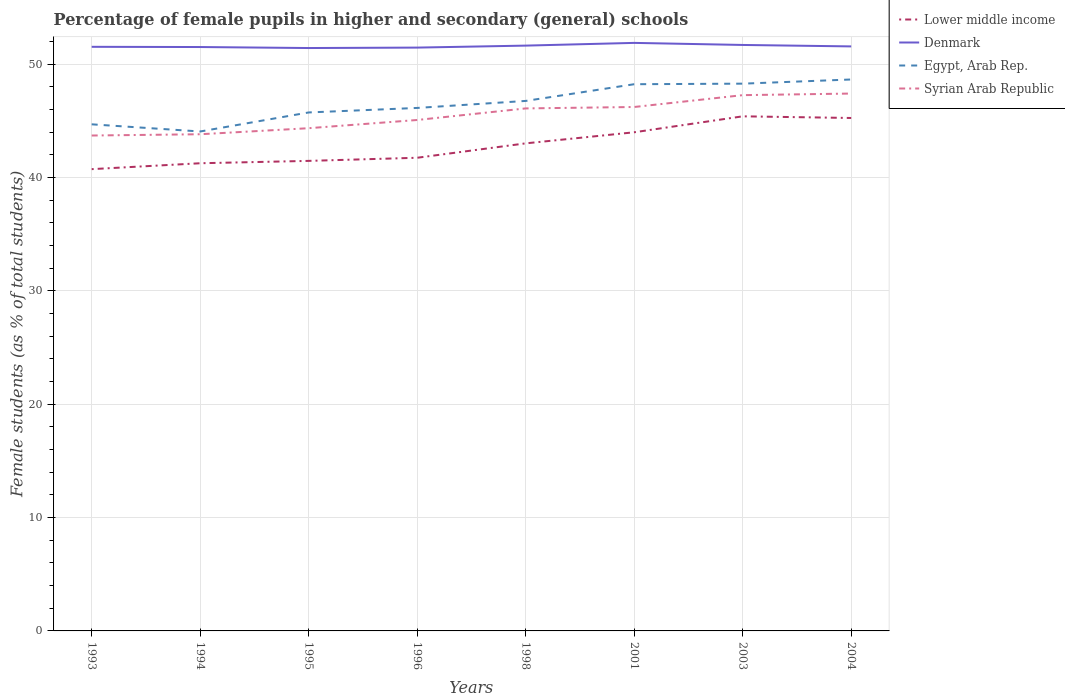Across all years, what is the maximum percentage of female pupils in higher and secondary schools in Lower middle income?
Make the answer very short. 40.74. In which year was the percentage of female pupils in higher and secondary schools in Denmark maximum?
Provide a succinct answer. 1995. What is the total percentage of female pupils in higher and secondary schools in Egypt, Arab Rep. in the graph?
Your response must be concise. -2.06. What is the difference between the highest and the second highest percentage of female pupils in higher and secondary schools in Egypt, Arab Rep.?
Your answer should be very brief. 4.59. Is the percentage of female pupils in higher and secondary schools in Lower middle income strictly greater than the percentage of female pupils in higher and secondary schools in Denmark over the years?
Offer a terse response. Yes. What is the difference between two consecutive major ticks on the Y-axis?
Your response must be concise. 10. Are the values on the major ticks of Y-axis written in scientific E-notation?
Provide a succinct answer. No. Does the graph contain grids?
Your answer should be compact. Yes. How many legend labels are there?
Keep it short and to the point. 4. What is the title of the graph?
Give a very brief answer. Percentage of female pupils in higher and secondary (general) schools. What is the label or title of the X-axis?
Provide a short and direct response. Years. What is the label or title of the Y-axis?
Your answer should be very brief. Female students (as % of total students). What is the Female students (as % of total students) in Lower middle income in 1993?
Keep it short and to the point. 40.74. What is the Female students (as % of total students) of Denmark in 1993?
Make the answer very short. 51.54. What is the Female students (as % of total students) of Egypt, Arab Rep. in 1993?
Make the answer very short. 44.7. What is the Female students (as % of total students) in Syrian Arab Republic in 1993?
Provide a short and direct response. 43.71. What is the Female students (as % of total students) of Lower middle income in 1994?
Make the answer very short. 41.27. What is the Female students (as % of total students) in Denmark in 1994?
Provide a short and direct response. 51.52. What is the Female students (as % of total students) of Egypt, Arab Rep. in 1994?
Keep it short and to the point. 44.07. What is the Female students (as % of total students) in Syrian Arab Republic in 1994?
Offer a terse response. 43.82. What is the Female students (as % of total students) of Lower middle income in 1995?
Keep it short and to the point. 41.47. What is the Female students (as % of total students) of Denmark in 1995?
Make the answer very short. 51.43. What is the Female students (as % of total students) of Egypt, Arab Rep. in 1995?
Keep it short and to the point. 45.75. What is the Female students (as % of total students) of Syrian Arab Republic in 1995?
Offer a terse response. 44.36. What is the Female students (as % of total students) of Lower middle income in 1996?
Provide a short and direct response. 41.75. What is the Female students (as % of total students) of Denmark in 1996?
Keep it short and to the point. 51.47. What is the Female students (as % of total students) in Egypt, Arab Rep. in 1996?
Give a very brief answer. 46.15. What is the Female students (as % of total students) in Syrian Arab Republic in 1996?
Your answer should be very brief. 45.08. What is the Female students (as % of total students) of Lower middle income in 1998?
Ensure brevity in your answer.  43.02. What is the Female students (as % of total students) in Denmark in 1998?
Provide a short and direct response. 51.65. What is the Female students (as % of total students) of Egypt, Arab Rep. in 1998?
Make the answer very short. 46.76. What is the Female students (as % of total students) in Syrian Arab Republic in 1998?
Your response must be concise. 46.1. What is the Female students (as % of total students) in Lower middle income in 2001?
Offer a very short reply. 44. What is the Female students (as % of total students) in Denmark in 2001?
Provide a short and direct response. 51.89. What is the Female students (as % of total students) of Egypt, Arab Rep. in 2001?
Give a very brief answer. 48.24. What is the Female students (as % of total students) of Syrian Arab Republic in 2001?
Your response must be concise. 46.23. What is the Female students (as % of total students) in Lower middle income in 2003?
Your answer should be compact. 45.41. What is the Female students (as % of total students) of Denmark in 2003?
Your answer should be compact. 51.7. What is the Female students (as % of total students) in Egypt, Arab Rep. in 2003?
Provide a succinct answer. 48.29. What is the Female students (as % of total students) in Syrian Arab Republic in 2003?
Keep it short and to the point. 47.27. What is the Female students (as % of total students) of Lower middle income in 2004?
Give a very brief answer. 45.26. What is the Female students (as % of total students) of Denmark in 2004?
Make the answer very short. 51.57. What is the Female students (as % of total students) of Egypt, Arab Rep. in 2004?
Give a very brief answer. 48.66. What is the Female students (as % of total students) in Syrian Arab Republic in 2004?
Your response must be concise. 47.42. Across all years, what is the maximum Female students (as % of total students) of Lower middle income?
Give a very brief answer. 45.41. Across all years, what is the maximum Female students (as % of total students) of Denmark?
Offer a very short reply. 51.89. Across all years, what is the maximum Female students (as % of total students) in Egypt, Arab Rep.?
Give a very brief answer. 48.66. Across all years, what is the maximum Female students (as % of total students) of Syrian Arab Republic?
Give a very brief answer. 47.42. Across all years, what is the minimum Female students (as % of total students) in Lower middle income?
Offer a terse response. 40.74. Across all years, what is the minimum Female students (as % of total students) of Denmark?
Offer a very short reply. 51.43. Across all years, what is the minimum Female students (as % of total students) in Egypt, Arab Rep.?
Provide a short and direct response. 44.07. Across all years, what is the minimum Female students (as % of total students) of Syrian Arab Republic?
Provide a succinct answer. 43.71. What is the total Female students (as % of total students) in Lower middle income in the graph?
Your answer should be compact. 342.92. What is the total Female students (as % of total students) of Denmark in the graph?
Keep it short and to the point. 412.77. What is the total Female students (as % of total students) of Egypt, Arab Rep. in the graph?
Provide a short and direct response. 372.61. What is the total Female students (as % of total students) in Syrian Arab Republic in the graph?
Make the answer very short. 364. What is the difference between the Female students (as % of total students) in Lower middle income in 1993 and that in 1994?
Provide a succinct answer. -0.52. What is the difference between the Female students (as % of total students) of Denmark in 1993 and that in 1994?
Offer a terse response. 0.02. What is the difference between the Female students (as % of total students) in Egypt, Arab Rep. in 1993 and that in 1994?
Your answer should be compact. 0.63. What is the difference between the Female students (as % of total students) in Syrian Arab Republic in 1993 and that in 1994?
Make the answer very short. -0.11. What is the difference between the Female students (as % of total students) in Lower middle income in 1993 and that in 1995?
Offer a terse response. -0.73. What is the difference between the Female students (as % of total students) of Denmark in 1993 and that in 1995?
Your answer should be compact. 0.11. What is the difference between the Female students (as % of total students) of Egypt, Arab Rep. in 1993 and that in 1995?
Provide a succinct answer. -1.05. What is the difference between the Female students (as % of total students) of Syrian Arab Republic in 1993 and that in 1995?
Your answer should be compact. -0.65. What is the difference between the Female students (as % of total students) in Lower middle income in 1993 and that in 1996?
Your answer should be very brief. -1.01. What is the difference between the Female students (as % of total students) of Denmark in 1993 and that in 1996?
Your answer should be compact. 0.07. What is the difference between the Female students (as % of total students) in Egypt, Arab Rep. in 1993 and that in 1996?
Ensure brevity in your answer.  -1.45. What is the difference between the Female students (as % of total students) in Syrian Arab Republic in 1993 and that in 1996?
Your response must be concise. -1.37. What is the difference between the Female students (as % of total students) of Lower middle income in 1993 and that in 1998?
Offer a terse response. -2.28. What is the difference between the Female students (as % of total students) in Denmark in 1993 and that in 1998?
Your answer should be compact. -0.11. What is the difference between the Female students (as % of total students) of Egypt, Arab Rep. in 1993 and that in 1998?
Ensure brevity in your answer.  -2.06. What is the difference between the Female students (as % of total students) in Syrian Arab Republic in 1993 and that in 1998?
Your answer should be very brief. -2.39. What is the difference between the Female students (as % of total students) of Lower middle income in 1993 and that in 2001?
Offer a terse response. -3.25. What is the difference between the Female students (as % of total students) in Denmark in 1993 and that in 2001?
Provide a short and direct response. -0.35. What is the difference between the Female students (as % of total students) of Egypt, Arab Rep. in 1993 and that in 2001?
Make the answer very short. -3.54. What is the difference between the Female students (as % of total students) in Syrian Arab Republic in 1993 and that in 2001?
Make the answer very short. -2.52. What is the difference between the Female students (as % of total students) in Lower middle income in 1993 and that in 2003?
Make the answer very short. -4.66. What is the difference between the Female students (as % of total students) in Denmark in 1993 and that in 2003?
Offer a very short reply. -0.17. What is the difference between the Female students (as % of total students) in Egypt, Arab Rep. in 1993 and that in 2003?
Your answer should be very brief. -3.59. What is the difference between the Female students (as % of total students) in Syrian Arab Republic in 1993 and that in 2003?
Offer a very short reply. -3.56. What is the difference between the Female students (as % of total students) in Lower middle income in 1993 and that in 2004?
Your answer should be very brief. -4.51. What is the difference between the Female students (as % of total students) in Denmark in 1993 and that in 2004?
Ensure brevity in your answer.  -0.04. What is the difference between the Female students (as % of total students) in Egypt, Arab Rep. in 1993 and that in 2004?
Keep it short and to the point. -3.96. What is the difference between the Female students (as % of total students) of Syrian Arab Republic in 1993 and that in 2004?
Make the answer very short. -3.7. What is the difference between the Female students (as % of total students) in Lower middle income in 1994 and that in 1995?
Offer a terse response. -0.21. What is the difference between the Female students (as % of total students) in Denmark in 1994 and that in 1995?
Provide a succinct answer. 0.09. What is the difference between the Female students (as % of total students) of Egypt, Arab Rep. in 1994 and that in 1995?
Give a very brief answer. -1.68. What is the difference between the Female students (as % of total students) in Syrian Arab Republic in 1994 and that in 1995?
Give a very brief answer. -0.53. What is the difference between the Female students (as % of total students) in Lower middle income in 1994 and that in 1996?
Provide a short and direct response. -0.48. What is the difference between the Female students (as % of total students) of Denmark in 1994 and that in 1996?
Offer a very short reply. 0.05. What is the difference between the Female students (as % of total students) in Egypt, Arab Rep. in 1994 and that in 1996?
Provide a short and direct response. -2.08. What is the difference between the Female students (as % of total students) of Syrian Arab Republic in 1994 and that in 1996?
Make the answer very short. -1.26. What is the difference between the Female students (as % of total students) of Lower middle income in 1994 and that in 1998?
Offer a terse response. -1.75. What is the difference between the Female students (as % of total students) in Denmark in 1994 and that in 1998?
Offer a very short reply. -0.13. What is the difference between the Female students (as % of total students) of Egypt, Arab Rep. in 1994 and that in 1998?
Give a very brief answer. -2.7. What is the difference between the Female students (as % of total students) of Syrian Arab Republic in 1994 and that in 1998?
Ensure brevity in your answer.  -2.28. What is the difference between the Female students (as % of total students) of Lower middle income in 1994 and that in 2001?
Your answer should be very brief. -2.73. What is the difference between the Female students (as % of total students) of Denmark in 1994 and that in 2001?
Your response must be concise. -0.37. What is the difference between the Female students (as % of total students) in Egypt, Arab Rep. in 1994 and that in 2001?
Your answer should be very brief. -4.17. What is the difference between the Female students (as % of total students) in Syrian Arab Republic in 1994 and that in 2001?
Your response must be concise. -2.4. What is the difference between the Female students (as % of total students) of Lower middle income in 1994 and that in 2003?
Your answer should be very brief. -4.14. What is the difference between the Female students (as % of total students) in Denmark in 1994 and that in 2003?
Your answer should be compact. -0.18. What is the difference between the Female students (as % of total students) of Egypt, Arab Rep. in 1994 and that in 2003?
Keep it short and to the point. -4.22. What is the difference between the Female students (as % of total students) of Syrian Arab Republic in 1994 and that in 2003?
Ensure brevity in your answer.  -3.45. What is the difference between the Female students (as % of total students) in Lower middle income in 1994 and that in 2004?
Make the answer very short. -3.99. What is the difference between the Female students (as % of total students) of Denmark in 1994 and that in 2004?
Offer a terse response. -0.06. What is the difference between the Female students (as % of total students) in Egypt, Arab Rep. in 1994 and that in 2004?
Your response must be concise. -4.59. What is the difference between the Female students (as % of total students) of Syrian Arab Republic in 1994 and that in 2004?
Provide a succinct answer. -3.59. What is the difference between the Female students (as % of total students) in Lower middle income in 1995 and that in 1996?
Provide a short and direct response. -0.28. What is the difference between the Female students (as % of total students) in Denmark in 1995 and that in 1996?
Your answer should be compact. -0.04. What is the difference between the Female students (as % of total students) in Egypt, Arab Rep. in 1995 and that in 1996?
Keep it short and to the point. -0.4. What is the difference between the Female students (as % of total students) of Syrian Arab Republic in 1995 and that in 1996?
Offer a very short reply. -0.72. What is the difference between the Female students (as % of total students) of Lower middle income in 1995 and that in 1998?
Offer a very short reply. -1.55. What is the difference between the Female students (as % of total students) in Denmark in 1995 and that in 1998?
Provide a succinct answer. -0.21. What is the difference between the Female students (as % of total students) in Egypt, Arab Rep. in 1995 and that in 1998?
Keep it short and to the point. -1.02. What is the difference between the Female students (as % of total students) of Syrian Arab Republic in 1995 and that in 1998?
Offer a terse response. -1.75. What is the difference between the Female students (as % of total students) in Lower middle income in 1995 and that in 2001?
Keep it short and to the point. -2.52. What is the difference between the Female students (as % of total students) of Denmark in 1995 and that in 2001?
Keep it short and to the point. -0.45. What is the difference between the Female students (as % of total students) in Egypt, Arab Rep. in 1995 and that in 2001?
Your answer should be very brief. -2.49. What is the difference between the Female students (as % of total students) of Syrian Arab Republic in 1995 and that in 2001?
Keep it short and to the point. -1.87. What is the difference between the Female students (as % of total students) of Lower middle income in 1995 and that in 2003?
Your answer should be compact. -3.93. What is the difference between the Female students (as % of total students) in Denmark in 1995 and that in 2003?
Offer a terse response. -0.27. What is the difference between the Female students (as % of total students) of Egypt, Arab Rep. in 1995 and that in 2003?
Your answer should be very brief. -2.54. What is the difference between the Female students (as % of total students) in Syrian Arab Republic in 1995 and that in 2003?
Offer a terse response. -2.92. What is the difference between the Female students (as % of total students) in Lower middle income in 1995 and that in 2004?
Ensure brevity in your answer.  -3.78. What is the difference between the Female students (as % of total students) in Denmark in 1995 and that in 2004?
Offer a very short reply. -0.14. What is the difference between the Female students (as % of total students) in Egypt, Arab Rep. in 1995 and that in 2004?
Your response must be concise. -2.91. What is the difference between the Female students (as % of total students) of Syrian Arab Republic in 1995 and that in 2004?
Ensure brevity in your answer.  -3.06. What is the difference between the Female students (as % of total students) of Lower middle income in 1996 and that in 1998?
Offer a very short reply. -1.27. What is the difference between the Female students (as % of total students) of Denmark in 1996 and that in 1998?
Offer a terse response. -0.18. What is the difference between the Female students (as % of total students) of Egypt, Arab Rep. in 1996 and that in 1998?
Provide a succinct answer. -0.62. What is the difference between the Female students (as % of total students) of Syrian Arab Republic in 1996 and that in 1998?
Your answer should be compact. -1.02. What is the difference between the Female students (as % of total students) of Lower middle income in 1996 and that in 2001?
Your answer should be compact. -2.25. What is the difference between the Female students (as % of total students) of Denmark in 1996 and that in 2001?
Your response must be concise. -0.41. What is the difference between the Female students (as % of total students) of Egypt, Arab Rep. in 1996 and that in 2001?
Your answer should be compact. -2.09. What is the difference between the Female students (as % of total students) in Syrian Arab Republic in 1996 and that in 2001?
Ensure brevity in your answer.  -1.15. What is the difference between the Female students (as % of total students) of Lower middle income in 1996 and that in 2003?
Provide a succinct answer. -3.66. What is the difference between the Female students (as % of total students) of Denmark in 1996 and that in 2003?
Give a very brief answer. -0.23. What is the difference between the Female students (as % of total students) of Egypt, Arab Rep. in 1996 and that in 2003?
Your answer should be very brief. -2.14. What is the difference between the Female students (as % of total students) of Syrian Arab Republic in 1996 and that in 2003?
Offer a very short reply. -2.19. What is the difference between the Female students (as % of total students) of Lower middle income in 1996 and that in 2004?
Offer a very short reply. -3.51. What is the difference between the Female students (as % of total students) of Denmark in 1996 and that in 2004?
Provide a short and direct response. -0.1. What is the difference between the Female students (as % of total students) of Egypt, Arab Rep. in 1996 and that in 2004?
Provide a succinct answer. -2.51. What is the difference between the Female students (as % of total students) of Syrian Arab Republic in 1996 and that in 2004?
Your response must be concise. -2.33. What is the difference between the Female students (as % of total students) in Lower middle income in 1998 and that in 2001?
Ensure brevity in your answer.  -0.98. What is the difference between the Female students (as % of total students) of Denmark in 1998 and that in 2001?
Keep it short and to the point. -0.24. What is the difference between the Female students (as % of total students) in Egypt, Arab Rep. in 1998 and that in 2001?
Give a very brief answer. -1.47. What is the difference between the Female students (as % of total students) of Syrian Arab Republic in 1998 and that in 2001?
Offer a terse response. -0.13. What is the difference between the Female students (as % of total students) in Lower middle income in 1998 and that in 2003?
Offer a terse response. -2.39. What is the difference between the Female students (as % of total students) in Denmark in 1998 and that in 2003?
Make the answer very short. -0.06. What is the difference between the Female students (as % of total students) of Egypt, Arab Rep. in 1998 and that in 2003?
Offer a very short reply. -1.52. What is the difference between the Female students (as % of total students) in Syrian Arab Republic in 1998 and that in 2003?
Give a very brief answer. -1.17. What is the difference between the Female students (as % of total students) of Lower middle income in 1998 and that in 2004?
Keep it short and to the point. -2.24. What is the difference between the Female students (as % of total students) of Denmark in 1998 and that in 2004?
Your response must be concise. 0.07. What is the difference between the Female students (as % of total students) in Egypt, Arab Rep. in 1998 and that in 2004?
Give a very brief answer. -1.89. What is the difference between the Female students (as % of total students) of Syrian Arab Republic in 1998 and that in 2004?
Your answer should be compact. -1.31. What is the difference between the Female students (as % of total students) of Lower middle income in 2001 and that in 2003?
Ensure brevity in your answer.  -1.41. What is the difference between the Female students (as % of total students) of Denmark in 2001 and that in 2003?
Your response must be concise. 0.18. What is the difference between the Female students (as % of total students) in Egypt, Arab Rep. in 2001 and that in 2003?
Give a very brief answer. -0.05. What is the difference between the Female students (as % of total students) of Syrian Arab Republic in 2001 and that in 2003?
Provide a short and direct response. -1.05. What is the difference between the Female students (as % of total students) in Lower middle income in 2001 and that in 2004?
Keep it short and to the point. -1.26. What is the difference between the Female students (as % of total students) of Denmark in 2001 and that in 2004?
Offer a very short reply. 0.31. What is the difference between the Female students (as % of total students) of Egypt, Arab Rep. in 2001 and that in 2004?
Give a very brief answer. -0.42. What is the difference between the Female students (as % of total students) in Syrian Arab Republic in 2001 and that in 2004?
Your response must be concise. -1.19. What is the difference between the Female students (as % of total students) of Lower middle income in 2003 and that in 2004?
Your answer should be very brief. 0.15. What is the difference between the Female students (as % of total students) of Denmark in 2003 and that in 2004?
Offer a very short reply. 0.13. What is the difference between the Female students (as % of total students) in Egypt, Arab Rep. in 2003 and that in 2004?
Your answer should be very brief. -0.37. What is the difference between the Female students (as % of total students) of Syrian Arab Republic in 2003 and that in 2004?
Offer a terse response. -0.14. What is the difference between the Female students (as % of total students) in Lower middle income in 1993 and the Female students (as % of total students) in Denmark in 1994?
Offer a very short reply. -10.78. What is the difference between the Female students (as % of total students) in Lower middle income in 1993 and the Female students (as % of total students) in Egypt, Arab Rep. in 1994?
Make the answer very short. -3.32. What is the difference between the Female students (as % of total students) of Lower middle income in 1993 and the Female students (as % of total students) of Syrian Arab Republic in 1994?
Your response must be concise. -3.08. What is the difference between the Female students (as % of total students) in Denmark in 1993 and the Female students (as % of total students) in Egypt, Arab Rep. in 1994?
Your response must be concise. 7.47. What is the difference between the Female students (as % of total students) of Denmark in 1993 and the Female students (as % of total students) of Syrian Arab Republic in 1994?
Keep it short and to the point. 7.71. What is the difference between the Female students (as % of total students) of Egypt, Arab Rep. in 1993 and the Female students (as % of total students) of Syrian Arab Republic in 1994?
Give a very brief answer. 0.88. What is the difference between the Female students (as % of total students) of Lower middle income in 1993 and the Female students (as % of total students) of Denmark in 1995?
Provide a short and direct response. -10.69. What is the difference between the Female students (as % of total students) of Lower middle income in 1993 and the Female students (as % of total students) of Egypt, Arab Rep. in 1995?
Keep it short and to the point. -5. What is the difference between the Female students (as % of total students) of Lower middle income in 1993 and the Female students (as % of total students) of Syrian Arab Republic in 1995?
Your response must be concise. -3.61. What is the difference between the Female students (as % of total students) in Denmark in 1993 and the Female students (as % of total students) in Egypt, Arab Rep. in 1995?
Your answer should be compact. 5.79. What is the difference between the Female students (as % of total students) in Denmark in 1993 and the Female students (as % of total students) in Syrian Arab Republic in 1995?
Your answer should be compact. 7.18. What is the difference between the Female students (as % of total students) of Egypt, Arab Rep. in 1993 and the Female students (as % of total students) of Syrian Arab Republic in 1995?
Your response must be concise. 0.34. What is the difference between the Female students (as % of total students) of Lower middle income in 1993 and the Female students (as % of total students) of Denmark in 1996?
Offer a very short reply. -10.73. What is the difference between the Female students (as % of total students) in Lower middle income in 1993 and the Female students (as % of total students) in Egypt, Arab Rep. in 1996?
Make the answer very short. -5.4. What is the difference between the Female students (as % of total students) of Lower middle income in 1993 and the Female students (as % of total students) of Syrian Arab Republic in 1996?
Your response must be concise. -4.34. What is the difference between the Female students (as % of total students) in Denmark in 1993 and the Female students (as % of total students) in Egypt, Arab Rep. in 1996?
Give a very brief answer. 5.39. What is the difference between the Female students (as % of total students) of Denmark in 1993 and the Female students (as % of total students) of Syrian Arab Republic in 1996?
Your answer should be very brief. 6.46. What is the difference between the Female students (as % of total students) of Egypt, Arab Rep. in 1993 and the Female students (as % of total students) of Syrian Arab Republic in 1996?
Provide a short and direct response. -0.38. What is the difference between the Female students (as % of total students) in Lower middle income in 1993 and the Female students (as % of total students) in Denmark in 1998?
Provide a succinct answer. -10.9. What is the difference between the Female students (as % of total students) of Lower middle income in 1993 and the Female students (as % of total students) of Egypt, Arab Rep. in 1998?
Offer a terse response. -6.02. What is the difference between the Female students (as % of total students) of Lower middle income in 1993 and the Female students (as % of total students) of Syrian Arab Republic in 1998?
Ensure brevity in your answer.  -5.36. What is the difference between the Female students (as % of total students) in Denmark in 1993 and the Female students (as % of total students) in Egypt, Arab Rep. in 1998?
Give a very brief answer. 4.77. What is the difference between the Female students (as % of total students) of Denmark in 1993 and the Female students (as % of total students) of Syrian Arab Republic in 1998?
Offer a very short reply. 5.44. What is the difference between the Female students (as % of total students) in Egypt, Arab Rep. in 1993 and the Female students (as % of total students) in Syrian Arab Republic in 1998?
Your answer should be compact. -1.4. What is the difference between the Female students (as % of total students) of Lower middle income in 1993 and the Female students (as % of total students) of Denmark in 2001?
Make the answer very short. -11.14. What is the difference between the Female students (as % of total students) in Lower middle income in 1993 and the Female students (as % of total students) in Egypt, Arab Rep. in 2001?
Make the answer very short. -7.49. What is the difference between the Female students (as % of total students) of Lower middle income in 1993 and the Female students (as % of total students) of Syrian Arab Republic in 2001?
Give a very brief answer. -5.48. What is the difference between the Female students (as % of total students) in Denmark in 1993 and the Female students (as % of total students) in Egypt, Arab Rep. in 2001?
Your answer should be compact. 3.3. What is the difference between the Female students (as % of total students) in Denmark in 1993 and the Female students (as % of total students) in Syrian Arab Republic in 2001?
Keep it short and to the point. 5.31. What is the difference between the Female students (as % of total students) in Egypt, Arab Rep. in 1993 and the Female students (as % of total students) in Syrian Arab Republic in 2001?
Ensure brevity in your answer.  -1.53. What is the difference between the Female students (as % of total students) of Lower middle income in 1993 and the Female students (as % of total students) of Denmark in 2003?
Keep it short and to the point. -10.96. What is the difference between the Female students (as % of total students) in Lower middle income in 1993 and the Female students (as % of total students) in Egypt, Arab Rep. in 2003?
Offer a terse response. -7.54. What is the difference between the Female students (as % of total students) of Lower middle income in 1993 and the Female students (as % of total students) of Syrian Arab Republic in 2003?
Your answer should be very brief. -6.53. What is the difference between the Female students (as % of total students) of Denmark in 1993 and the Female students (as % of total students) of Egypt, Arab Rep. in 2003?
Ensure brevity in your answer.  3.25. What is the difference between the Female students (as % of total students) in Denmark in 1993 and the Female students (as % of total students) in Syrian Arab Republic in 2003?
Ensure brevity in your answer.  4.26. What is the difference between the Female students (as % of total students) of Egypt, Arab Rep. in 1993 and the Female students (as % of total students) of Syrian Arab Republic in 2003?
Ensure brevity in your answer.  -2.57. What is the difference between the Female students (as % of total students) in Lower middle income in 1993 and the Female students (as % of total students) in Denmark in 2004?
Make the answer very short. -10.83. What is the difference between the Female students (as % of total students) in Lower middle income in 1993 and the Female students (as % of total students) in Egypt, Arab Rep. in 2004?
Ensure brevity in your answer.  -7.91. What is the difference between the Female students (as % of total students) of Lower middle income in 1993 and the Female students (as % of total students) of Syrian Arab Republic in 2004?
Offer a terse response. -6.67. What is the difference between the Female students (as % of total students) in Denmark in 1993 and the Female students (as % of total students) in Egypt, Arab Rep. in 2004?
Your response must be concise. 2.88. What is the difference between the Female students (as % of total students) in Denmark in 1993 and the Female students (as % of total students) in Syrian Arab Republic in 2004?
Keep it short and to the point. 4.12. What is the difference between the Female students (as % of total students) of Egypt, Arab Rep. in 1993 and the Female students (as % of total students) of Syrian Arab Republic in 2004?
Your answer should be very brief. -2.71. What is the difference between the Female students (as % of total students) of Lower middle income in 1994 and the Female students (as % of total students) of Denmark in 1995?
Make the answer very short. -10.17. What is the difference between the Female students (as % of total students) in Lower middle income in 1994 and the Female students (as % of total students) in Egypt, Arab Rep. in 1995?
Provide a short and direct response. -4.48. What is the difference between the Female students (as % of total students) of Lower middle income in 1994 and the Female students (as % of total students) of Syrian Arab Republic in 1995?
Your response must be concise. -3.09. What is the difference between the Female students (as % of total students) in Denmark in 1994 and the Female students (as % of total students) in Egypt, Arab Rep. in 1995?
Your answer should be compact. 5.77. What is the difference between the Female students (as % of total students) in Denmark in 1994 and the Female students (as % of total students) in Syrian Arab Republic in 1995?
Ensure brevity in your answer.  7.16. What is the difference between the Female students (as % of total students) in Egypt, Arab Rep. in 1994 and the Female students (as % of total students) in Syrian Arab Republic in 1995?
Your response must be concise. -0.29. What is the difference between the Female students (as % of total students) in Lower middle income in 1994 and the Female students (as % of total students) in Denmark in 1996?
Offer a terse response. -10.2. What is the difference between the Female students (as % of total students) in Lower middle income in 1994 and the Female students (as % of total students) in Egypt, Arab Rep. in 1996?
Offer a very short reply. -4.88. What is the difference between the Female students (as % of total students) of Lower middle income in 1994 and the Female students (as % of total students) of Syrian Arab Republic in 1996?
Offer a terse response. -3.82. What is the difference between the Female students (as % of total students) of Denmark in 1994 and the Female students (as % of total students) of Egypt, Arab Rep. in 1996?
Make the answer very short. 5.37. What is the difference between the Female students (as % of total students) of Denmark in 1994 and the Female students (as % of total students) of Syrian Arab Republic in 1996?
Provide a succinct answer. 6.44. What is the difference between the Female students (as % of total students) in Egypt, Arab Rep. in 1994 and the Female students (as % of total students) in Syrian Arab Republic in 1996?
Offer a terse response. -1.01. What is the difference between the Female students (as % of total students) in Lower middle income in 1994 and the Female students (as % of total students) in Denmark in 1998?
Make the answer very short. -10.38. What is the difference between the Female students (as % of total students) of Lower middle income in 1994 and the Female students (as % of total students) of Egypt, Arab Rep. in 1998?
Your answer should be very brief. -5.5. What is the difference between the Female students (as % of total students) of Lower middle income in 1994 and the Female students (as % of total students) of Syrian Arab Republic in 1998?
Make the answer very short. -4.84. What is the difference between the Female students (as % of total students) in Denmark in 1994 and the Female students (as % of total students) in Egypt, Arab Rep. in 1998?
Your response must be concise. 4.76. What is the difference between the Female students (as % of total students) in Denmark in 1994 and the Female students (as % of total students) in Syrian Arab Republic in 1998?
Offer a terse response. 5.42. What is the difference between the Female students (as % of total students) in Egypt, Arab Rep. in 1994 and the Female students (as % of total students) in Syrian Arab Republic in 1998?
Give a very brief answer. -2.04. What is the difference between the Female students (as % of total students) in Lower middle income in 1994 and the Female students (as % of total students) in Denmark in 2001?
Give a very brief answer. -10.62. What is the difference between the Female students (as % of total students) in Lower middle income in 1994 and the Female students (as % of total students) in Egypt, Arab Rep. in 2001?
Provide a succinct answer. -6.97. What is the difference between the Female students (as % of total students) in Lower middle income in 1994 and the Female students (as % of total students) in Syrian Arab Republic in 2001?
Make the answer very short. -4.96. What is the difference between the Female students (as % of total students) of Denmark in 1994 and the Female students (as % of total students) of Egypt, Arab Rep. in 2001?
Your answer should be very brief. 3.28. What is the difference between the Female students (as % of total students) of Denmark in 1994 and the Female students (as % of total students) of Syrian Arab Republic in 2001?
Your answer should be very brief. 5.29. What is the difference between the Female students (as % of total students) in Egypt, Arab Rep. in 1994 and the Female students (as % of total students) in Syrian Arab Republic in 2001?
Make the answer very short. -2.16. What is the difference between the Female students (as % of total students) of Lower middle income in 1994 and the Female students (as % of total students) of Denmark in 2003?
Ensure brevity in your answer.  -10.44. What is the difference between the Female students (as % of total students) in Lower middle income in 1994 and the Female students (as % of total students) in Egypt, Arab Rep. in 2003?
Your answer should be compact. -7.02. What is the difference between the Female students (as % of total students) in Lower middle income in 1994 and the Female students (as % of total students) in Syrian Arab Republic in 2003?
Offer a terse response. -6.01. What is the difference between the Female students (as % of total students) in Denmark in 1994 and the Female students (as % of total students) in Egypt, Arab Rep. in 2003?
Offer a terse response. 3.23. What is the difference between the Female students (as % of total students) of Denmark in 1994 and the Female students (as % of total students) of Syrian Arab Republic in 2003?
Your answer should be very brief. 4.25. What is the difference between the Female students (as % of total students) in Egypt, Arab Rep. in 1994 and the Female students (as % of total students) in Syrian Arab Republic in 2003?
Provide a succinct answer. -3.21. What is the difference between the Female students (as % of total students) of Lower middle income in 1994 and the Female students (as % of total students) of Denmark in 2004?
Your answer should be very brief. -10.31. What is the difference between the Female students (as % of total students) of Lower middle income in 1994 and the Female students (as % of total students) of Egypt, Arab Rep. in 2004?
Give a very brief answer. -7.39. What is the difference between the Female students (as % of total students) of Lower middle income in 1994 and the Female students (as % of total students) of Syrian Arab Republic in 2004?
Provide a succinct answer. -6.15. What is the difference between the Female students (as % of total students) in Denmark in 1994 and the Female students (as % of total students) in Egypt, Arab Rep. in 2004?
Your response must be concise. 2.86. What is the difference between the Female students (as % of total students) in Denmark in 1994 and the Female students (as % of total students) in Syrian Arab Republic in 2004?
Your response must be concise. 4.1. What is the difference between the Female students (as % of total students) of Egypt, Arab Rep. in 1994 and the Female students (as % of total students) of Syrian Arab Republic in 2004?
Give a very brief answer. -3.35. What is the difference between the Female students (as % of total students) in Lower middle income in 1995 and the Female students (as % of total students) in Denmark in 1996?
Make the answer very short. -10. What is the difference between the Female students (as % of total students) of Lower middle income in 1995 and the Female students (as % of total students) of Egypt, Arab Rep. in 1996?
Your answer should be very brief. -4.67. What is the difference between the Female students (as % of total students) in Lower middle income in 1995 and the Female students (as % of total students) in Syrian Arab Republic in 1996?
Give a very brief answer. -3.61. What is the difference between the Female students (as % of total students) of Denmark in 1995 and the Female students (as % of total students) of Egypt, Arab Rep. in 1996?
Provide a short and direct response. 5.29. What is the difference between the Female students (as % of total students) of Denmark in 1995 and the Female students (as % of total students) of Syrian Arab Republic in 1996?
Your answer should be compact. 6.35. What is the difference between the Female students (as % of total students) of Egypt, Arab Rep. in 1995 and the Female students (as % of total students) of Syrian Arab Republic in 1996?
Offer a very short reply. 0.67. What is the difference between the Female students (as % of total students) of Lower middle income in 1995 and the Female students (as % of total students) of Denmark in 1998?
Your answer should be very brief. -10.17. What is the difference between the Female students (as % of total students) of Lower middle income in 1995 and the Female students (as % of total students) of Egypt, Arab Rep. in 1998?
Your answer should be compact. -5.29. What is the difference between the Female students (as % of total students) of Lower middle income in 1995 and the Female students (as % of total students) of Syrian Arab Republic in 1998?
Ensure brevity in your answer.  -4.63. What is the difference between the Female students (as % of total students) in Denmark in 1995 and the Female students (as % of total students) in Egypt, Arab Rep. in 1998?
Your response must be concise. 4.67. What is the difference between the Female students (as % of total students) of Denmark in 1995 and the Female students (as % of total students) of Syrian Arab Republic in 1998?
Your answer should be very brief. 5.33. What is the difference between the Female students (as % of total students) of Egypt, Arab Rep. in 1995 and the Female students (as % of total students) of Syrian Arab Republic in 1998?
Ensure brevity in your answer.  -0.36. What is the difference between the Female students (as % of total students) in Lower middle income in 1995 and the Female students (as % of total students) in Denmark in 2001?
Give a very brief answer. -10.41. What is the difference between the Female students (as % of total students) in Lower middle income in 1995 and the Female students (as % of total students) in Egypt, Arab Rep. in 2001?
Offer a terse response. -6.76. What is the difference between the Female students (as % of total students) of Lower middle income in 1995 and the Female students (as % of total students) of Syrian Arab Republic in 2001?
Your answer should be compact. -4.75. What is the difference between the Female students (as % of total students) in Denmark in 1995 and the Female students (as % of total students) in Egypt, Arab Rep. in 2001?
Offer a very short reply. 3.19. What is the difference between the Female students (as % of total students) in Denmark in 1995 and the Female students (as % of total students) in Syrian Arab Republic in 2001?
Your answer should be compact. 5.2. What is the difference between the Female students (as % of total students) in Egypt, Arab Rep. in 1995 and the Female students (as % of total students) in Syrian Arab Republic in 2001?
Offer a terse response. -0.48. What is the difference between the Female students (as % of total students) of Lower middle income in 1995 and the Female students (as % of total students) of Denmark in 2003?
Offer a terse response. -10.23. What is the difference between the Female students (as % of total students) of Lower middle income in 1995 and the Female students (as % of total students) of Egypt, Arab Rep. in 2003?
Make the answer very short. -6.81. What is the difference between the Female students (as % of total students) of Lower middle income in 1995 and the Female students (as % of total students) of Syrian Arab Republic in 2003?
Give a very brief answer. -5.8. What is the difference between the Female students (as % of total students) of Denmark in 1995 and the Female students (as % of total students) of Egypt, Arab Rep. in 2003?
Your response must be concise. 3.14. What is the difference between the Female students (as % of total students) of Denmark in 1995 and the Female students (as % of total students) of Syrian Arab Republic in 2003?
Make the answer very short. 4.16. What is the difference between the Female students (as % of total students) in Egypt, Arab Rep. in 1995 and the Female students (as % of total students) in Syrian Arab Republic in 2003?
Provide a short and direct response. -1.53. What is the difference between the Female students (as % of total students) of Lower middle income in 1995 and the Female students (as % of total students) of Denmark in 2004?
Your answer should be very brief. -10.1. What is the difference between the Female students (as % of total students) in Lower middle income in 1995 and the Female students (as % of total students) in Egypt, Arab Rep. in 2004?
Give a very brief answer. -7.18. What is the difference between the Female students (as % of total students) in Lower middle income in 1995 and the Female students (as % of total students) in Syrian Arab Republic in 2004?
Keep it short and to the point. -5.94. What is the difference between the Female students (as % of total students) of Denmark in 1995 and the Female students (as % of total students) of Egypt, Arab Rep. in 2004?
Your answer should be very brief. 2.77. What is the difference between the Female students (as % of total students) in Denmark in 1995 and the Female students (as % of total students) in Syrian Arab Republic in 2004?
Provide a short and direct response. 4.02. What is the difference between the Female students (as % of total students) in Egypt, Arab Rep. in 1995 and the Female students (as % of total students) in Syrian Arab Republic in 2004?
Your answer should be compact. -1.67. What is the difference between the Female students (as % of total students) of Lower middle income in 1996 and the Female students (as % of total students) of Denmark in 1998?
Give a very brief answer. -9.9. What is the difference between the Female students (as % of total students) in Lower middle income in 1996 and the Female students (as % of total students) in Egypt, Arab Rep. in 1998?
Give a very brief answer. -5.01. What is the difference between the Female students (as % of total students) in Lower middle income in 1996 and the Female students (as % of total students) in Syrian Arab Republic in 1998?
Provide a short and direct response. -4.35. What is the difference between the Female students (as % of total students) of Denmark in 1996 and the Female students (as % of total students) of Egypt, Arab Rep. in 1998?
Your answer should be very brief. 4.71. What is the difference between the Female students (as % of total students) of Denmark in 1996 and the Female students (as % of total students) of Syrian Arab Republic in 1998?
Give a very brief answer. 5.37. What is the difference between the Female students (as % of total students) of Egypt, Arab Rep. in 1996 and the Female students (as % of total students) of Syrian Arab Republic in 1998?
Ensure brevity in your answer.  0.04. What is the difference between the Female students (as % of total students) in Lower middle income in 1996 and the Female students (as % of total students) in Denmark in 2001?
Keep it short and to the point. -10.14. What is the difference between the Female students (as % of total students) in Lower middle income in 1996 and the Female students (as % of total students) in Egypt, Arab Rep. in 2001?
Ensure brevity in your answer.  -6.49. What is the difference between the Female students (as % of total students) in Lower middle income in 1996 and the Female students (as % of total students) in Syrian Arab Republic in 2001?
Ensure brevity in your answer.  -4.48. What is the difference between the Female students (as % of total students) in Denmark in 1996 and the Female students (as % of total students) in Egypt, Arab Rep. in 2001?
Offer a very short reply. 3.23. What is the difference between the Female students (as % of total students) in Denmark in 1996 and the Female students (as % of total students) in Syrian Arab Republic in 2001?
Make the answer very short. 5.24. What is the difference between the Female students (as % of total students) of Egypt, Arab Rep. in 1996 and the Female students (as % of total students) of Syrian Arab Republic in 2001?
Provide a short and direct response. -0.08. What is the difference between the Female students (as % of total students) of Lower middle income in 1996 and the Female students (as % of total students) of Denmark in 2003?
Offer a terse response. -9.95. What is the difference between the Female students (as % of total students) of Lower middle income in 1996 and the Female students (as % of total students) of Egypt, Arab Rep. in 2003?
Provide a short and direct response. -6.54. What is the difference between the Female students (as % of total students) of Lower middle income in 1996 and the Female students (as % of total students) of Syrian Arab Republic in 2003?
Ensure brevity in your answer.  -5.52. What is the difference between the Female students (as % of total students) in Denmark in 1996 and the Female students (as % of total students) in Egypt, Arab Rep. in 2003?
Provide a succinct answer. 3.18. What is the difference between the Female students (as % of total students) in Denmark in 1996 and the Female students (as % of total students) in Syrian Arab Republic in 2003?
Keep it short and to the point. 4.2. What is the difference between the Female students (as % of total students) in Egypt, Arab Rep. in 1996 and the Female students (as % of total students) in Syrian Arab Republic in 2003?
Offer a very short reply. -1.13. What is the difference between the Female students (as % of total students) in Lower middle income in 1996 and the Female students (as % of total students) in Denmark in 2004?
Offer a very short reply. -9.83. What is the difference between the Female students (as % of total students) of Lower middle income in 1996 and the Female students (as % of total students) of Egypt, Arab Rep. in 2004?
Keep it short and to the point. -6.91. What is the difference between the Female students (as % of total students) in Lower middle income in 1996 and the Female students (as % of total students) in Syrian Arab Republic in 2004?
Provide a succinct answer. -5.67. What is the difference between the Female students (as % of total students) of Denmark in 1996 and the Female students (as % of total students) of Egypt, Arab Rep. in 2004?
Offer a terse response. 2.81. What is the difference between the Female students (as % of total students) of Denmark in 1996 and the Female students (as % of total students) of Syrian Arab Republic in 2004?
Offer a terse response. 4.06. What is the difference between the Female students (as % of total students) of Egypt, Arab Rep. in 1996 and the Female students (as % of total students) of Syrian Arab Republic in 2004?
Your answer should be very brief. -1.27. What is the difference between the Female students (as % of total students) of Lower middle income in 1998 and the Female students (as % of total students) of Denmark in 2001?
Offer a terse response. -8.86. What is the difference between the Female students (as % of total students) in Lower middle income in 1998 and the Female students (as % of total students) in Egypt, Arab Rep. in 2001?
Make the answer very short. -5.22. What is the difference between the Female students (as % of total students) in Lower middle income in 1998 and the Female students (as % of total students) in Syrian Arab Republic in 2001?
Make the answer very short. -3.21. What is the difference between the Female students (as % of total students) in Denmark in 1998 and the Female students (as % of total students) in Egypt, Arab Rep. in 2001?
Provide a succinct answer. 3.41. What is the difference between the Female students (as % of total students) of Denmark in 1998 and the Female students (as % of total students) of Syrian Arab Republic in 2001?
Your answer should be very brief. 5.42. What is the difference between the Female students (as % of total students) of Egypt, Arab Rep. in 1998 and the Female students (as % of total students) of Syrian Arab Republic in 2001?
Make the answer very short. 0.54. What is the difference between the Female students (as % of total students) of Lower middle income in 1998 and the Female students (as % of total students) of Denmark in 2003?
Keep it short and to the point. -8.68. What is the difference between the Female students (as % of total students) in Lower middle income in 1998 and the Female students (as % of total students) in Egypt, Arab Rep. in 2003?
Your answer should be compact. -5.27. What is the difference between the Female students (as % of total students) in Lower middle income in 1998 and the Female students (as % of total students) in Syrian Arab Republic in 2003?
Your answer should be very brief. -4.25. What is the difference between the Female students (as % of total students) in Denmark in 1998 and the Female students (as % of total students) in Egypt, Arab Rep. in 2003?
Provide a short and direct response. 3.36. What is the difference between the Female students (as % of total students) of Denmark in 1998 and the Female students (as % of total students) of Syrian Arab Republic in 2003?
Provide a short and direct response. 4.37. What is the difference between the Female students (as % of total students) of Egypt, Arab Rep. in 1998 and the Female students (as % of total students) of Syrian Arab Republic in 2003?
Your answer should be very brief. -0.51. What is the difference between the Female students (as % of total students) of Lower middle income in 1998 and the Female students (as % of total students) of Denmark in 2004?
Make the answer very short. -8.55. What is the difference between the Female students (as % of total students) in Lower middle income in 1998 and the Female students (as % of total students) in Egypt, Arab Rep. in 2004?
Your answer should be very brief. -5.64. What is the difference between the Female students (as % of total students) in Lower middle income in 1998 and the Female students (as % of total students) in Syrian Arab Republic in 2004?
Your response must be concise. -4.39. What is the difference between the Female students (as % of total students) in Denmark in 1998 and the Female students (as % of total students) in Egypt, Arab Rep. in 2004?
Ensure brevity in your answer.  2.99. What is the difference between the Female students (as % of total students) of Denmark in 1998 and the Female students (as % of total students) of Syrian Arab Republic in 2004?
Make the answer very short. 4.23. What is the difference between the Female students (as % of total students) of Egypt, Arab Rep. in 1998 and the Female students (as % of total students) of Syrian Arab Republic in 2004?
Offer a very short reply. -0.65. What is the difference between the Female students (as % of total students) in Lower middle income in 2001 and the Female students (as % of total students) in Denmark in 2003?
Your answer should be compact. -7.71. What is the difference between the Female students (as % of total students) of Lower middle income in 2001 and the Female students (as % of total students) of Egypt, Arab Rep. in 2003?
Ensure brevity in your answer.  -4.29. What is the difference between the Female students (as % of total students) of Lower middle income in 2001 and the Female students (as % of total students) of Syrian Arab Republic in 2003?
Your answer should be compact. -3.28. What is the difference between the Female students (as % of total students) in Denmark in 2001 and the Female students (as % of total students) in Egypt, Arab Rep. in 2003?
Provide a short and direct response. 3.6. What is the difference between the Female students (as % of total students) of Denmark in 2001 and the Female students (as % of total students) of Syrian Arab Republic in 2003?
Your response must be concise. 4.61. What is the difference between the Female students (as % of total students) in Egypt, Arab Rep. in 2001 and the Female students (as % of total students) in Syrian Arab Republic in 2003?
Offer a terse response. 0.96. What is the difference between the Female students (as % of total students) in Lower middle income in 2001 and the Female students (as % of total students) in Denmark in 2004?
Your response must be concise. -7.58. What is the difference between the Female students (as % of total students) in Lower middle income in 2001 and the Female students (as % of total students) in Egypt, Arab Rep. in 2004?
Offer a terse response. -4.66. What is the difference between the Female students (as % of total students) of Lower middle income in 2001 and the Female students (as % of total students) of Syrian Arab Republic in 2004?
Offer a very short reply. -3.42. What is the difference between the Female students (as % of total students) in Denmark in 2001 and the Female students (as % of total students) in Egypt, Arab Rep. in 2004?
Your response must be concise. 3.23. What is the difference between the Female students (as % of total students) of Denmark in 2001 and the Female students (as % of total students) of Syrian Arab Republic in 2004?
Offer a terse response. 4.47. What is the difference between the Female students (as % of total students) in Egypt, Arab Rep. in 2001 and the Female students (as % of total students) in Syrian Arab Republic in 2004?
Provide a succinct answer. 0.82. What is the difference between the Female students (as % of total students) in Lower middle income in 2003 and the Female students (as % of total students) in Denmark in 2004?
Keep it short and to the point. -6.17. What is the difference between the Female students (as % of total students) in Lower middle income in 2003 and the Female students (as % of total students) in Egypt, Arab Rep. in 2004?
Your answer should be very brief. -3.25. What is the difference between the Female students (as % of total students) in Lower middle income in 2003 and the Female students (as % of total students) in Syrian Arab Republic in 2004?
Offer a very short reply. -2.01. What is the difference between the Female students (as % of total students) of Denmark in 2003 and the Female students (as % of total students) of Egypt, Arab Rep. in 2004?
Provide a succinct answer. 3.05. What is the difference between the Female students (as % of total students) in Denmark in 2003 and the Female students (as % of total students) in Syrian Arab Republic in 2004?
Give a very brief answer. 4.29. What is the difference between the Female students (as % of total students) in Egypt, Arab Rep. in 2003 and the Female students (as % of total students) in Syrian Arab Republic in 2004?
Your answer should be very brief. 0.87. What is the average Female students (as % of total students) of Lower middle income per year?
Provide a succinct answer. 42.86. What is the average Female students (as % of total students) of Denmark per year?
Offer a very short reply. 51.6. What is the average Female students (as % of total students) of Egypt, Arab Rep. per year?
Make the answer very short. 46.58. What is the average Female students (as % of total students) in Syrian Arab Republic per year?
Provide a succinct answer. 45.5. In the year 1993, what is the difference between the Female students (as % of total students) in Lower middle income and Female students (as % of total students) in Denmark?
Offer a terse response. -10.79. In the year 1993, what is the difference between the Female students (as % of total students) in Lower middle income and Female students (as % of total students) in Egypt, Arab Rep.?
Provide a short and direct response. -3.96. In the year 1993, what is the difference between the Female students (as % of total students) in Lower middle income and Female students (as % of total students) in Syrian Arab Republic?
Ensure brevity in your answer.  -2.97. In the year 1993, what is the difference between the Female students (as % of total students) of Denmark and Female students (as % of total students) of Egypt, Arab Rep.?
Your response must be concise. 6.84. In the year 1993, what is the difference between the Female students (as % of total students) in Denmark and Female students (as % of total students) in Syrian Arab Republic?
Make the answer very short. 7.83. In the year 1993, what is the difference between the Female students (as % of total students) in Egypt, Arab Rep. and Female students (as % of total students) in Syrian Arab Republic?
Your response must be concise. 0.99. In the year 1994, what is the difference between the Female students (as % of total students) of Lower middle income and Female students (as % of total students) of Denmark?
Keep it short and to the point. -10.25. In the year 1994, what is the difference between the Female students (as % of total students) of Lower middle income and Female students (as % of total students) of Egypt, Arab Rep.?
Offer a very short reply. -2.8. In the year 1994, what is the difference between the Female students (as % of total students) in Lower middle income and Female students (as % of total students) in Syrian Arab Republic?
Your answer should be compact. -2.56. In the year 1994, what is the difference between the Female students (as % of total students) of Denmark and Female students (as % of total students) of Egypt, Arab Rep.?
Offer a very short reply. 7.45. In the year 1994, what is the difference between the Female students (as % of total students) of Denmark and Female students (as % of total students) of Syrian Arab Republic?
Give a very brief answer. 7.7. In the year 1994, what is the difference between the Female students (as % of total students) in Egypt, Arab Rep. and Female students (as % of total students) in Syrian Arab Republic?
Offer a very short reply. 0.24. In the year 1995, what is the difference between the Female students (as % of total students) in Lower middle income and Female students (as % of total students) in Denmark?
Offer a terse response. -9.96. In the year 1995, what is the difference between the Female students (as % of total students) of Lower middle income and Female students (as % of total students) of Egypt, Arab Rep.?
Make the answer very short. -4.27. In the year 1995, what is the difference between the Female students (as % of total students) in Lower middle income and Female students (as % of total students) in Syrian Arab Republic?
Offer a very short reply. -2.88. In the year 1995, what is the difference between the Female students (as % of total students) of Denmark and Female students (as % of total students) of Egypt, Arab Rep.?
Your response must be concise. 5.68. In the year 1995, what is the difference between the Female students (as % of total students) in Denmark and Female students (as % of total students) in Syrian Arab Republic?
Keep it short and to the point. 7.07. In the year 1995, what is the difference between the Female students (as % of total students) of Egypt, Arab Rep. and Female students (as % of total students) of Syrian Arab Republic?
Make the answer very short. 1.39. In the year 1996, what is the difference between the Female students (as % of total students) in Lower middle income and Female students (as % of total students) in Denmark?
Make the answer very short. -9.72. In the year 1996, what is the difference between the Female students (as % of total students) of Lower middle income and Female students (as % of total students) of Egypt, Arab Rep.?
Ensure brevity in your answer.  -4.4. In the year 1996, what is the difference between the Female students (as % of total students) in Lower middle income and Female students (as % of total students) in Syrian Arab Republic?
Ensure brevity in your answer.  -3.33. In the year 1996, what is the difference between the Female students (as % of total students) of Denmark and Female students (as % of total students) of Egypt, Arab Rep.?
Offer a very short reply. 5.33. In the year 1996, what is the difference between the Female students (as % of total students) of Denmark and Female students (as % of total students) of Syrian Arab Republic?
Provide a short and direct response. 6.39. In the year 1996, what is the difference between the Female students (as % of total students) of Egypt, Arab Rep. and Female students (as % of total students) of Syrian Arab Republic?
Offer a very short reply. 1.06. In the year 1998, what is the difference between the Female students (as % of total students) of Lower middle income and Female students (as % of total students) of Denmark?
Your answer should be compact. -8.63. In the year 1998, what is the difference between the Female students (as % of total students) of Lower middle income and Female students (as % of total students) of Egypt, Arab Rep.?
Offer a very short reply. -3.74. In the year 1998, what is the difference between the Female students (as % of total students) in Lower middle income and Female students (as % of total students) in Syrian Arab Republic?
Ensure brevity in your answer.  -3.08. In the year 1998, what is the difference between the Female students (as % of total students) of Denmark and Female students (as % of total students) of Egypt, Arab Rep.?
Your answer should be compact. 4.88. In the year 1998, what is the difference between the Female students (as % of total students) in Denmark and Female students (as % of total students) in Syrian Arab Republic?
Offer a terse response. 5.54. In the year 1998, what is the difference between the Female students (as % of total students) of Egypt, Arab Rep. and Female students (as % of total students) of Syrian Arab Republic?
Keep it short and to the point. 0.66. In the year 2001, what is the difference between the Female students (as % of total students) in Lower middle income and Female students (as % of total students) in Denmark?
Provide a succinct answer. -7.89. In the year 2001, what is the difference between the Female students (as % of total students) of Lower middle income and Female students (as % of total students) of Egypt, Arab Rep.?
Provide a short and direct response. -4.24. In the year 2001, what is the difference between the Female students (as % of total students) of Lower middle income and Female students (as % of total students) of Syrian Arab Republic?
Ensure brevity in your answer.  -2.23. In the year 2001, what is the difference between the Female students (as % of total students) in Denmark and Female students (as % of total students) in Egypt, Arab Rep.?
Ensure brevity in your answer.  3.65. In the year 2001, what is the difference between the Female students (as % of total students) of Denmark and Female students (as % of total students) of Syrian Arab Republic?
Give a very brief answer. 5.66. In the year 2001, what is the difference between the Female students (as % of total students) in Egypt, Arab Rep. and Female students (as % of total students) in Syrian Arab Republic?
Keep it short and to the point. 2.01. In the year 2003, what is the difference between the Female students (as % of total students) in Lower middle income and Female students (as % of total students) in Denmark?
Your response must be concise. -6.3. In the year 2003, what is the difference between the Female students (as % of total students) in Lower middle income and Female students (as % of total students) in Egypt, Arab Rep.?
Your answer should be very brief. -2.88. In the year 2003, what is the difference between the Female students (as % of total students) of Lower middle income and Female students (as % of total students) of Syrian Arab Republic?
Your response must be concise. -1.87. In the year 2003, what is the difference between the Female students (as % of total students) in Denmark and Female students (as % of total students) in Egypt, Arab Rep.?
Keep it short and to the point. 3.42. In the year 2003, what is the difference between the Female students (as % of total students) of Denmark and Female students (as % of total students) of Syrian Arab Republic?
Offer a very short reply. 4.43. In the year 2003, what is the difference between the Female students (as % of total students) in Egypt, Arab Rep. and Female students (as % of total students) in Syrian Arab Republic?
Your answer should be very brief. 1.01. In the year 2004, what is the difference between the Female students (as % of total students) in Lower middle income and Female students (as % of total students) in Denmark?
Your answer should be compact. -6.32. In the year 2004, what is the difference between the Female students (as % of total students) of Lower middle income and Female students (as % of total students) of Egypt, Arab Rep.?
Give a very brief answer. -3.4. In the year 2004, what is the difference between the Female students (as % of total students) in Lower middle income and Female students (as % of total students) in Syrian Arab Republic?
Give a very brief answer. -2.16. In the year 2004, what is the difference between the Female students (as % of total students) of Denmark and Female students (as % of total students) of Egypt, Arab Rep.?
Your response must be concise. 2.92. In the year 2004, what is the difference between the Female students (as % of total students) of Denmark and Female students (as % of total students) of Syrian Arab Republic?
Offer a very short reply. 4.16. In the year 2004, what is the difference between the Female students (as % of total students) in Egypt, Arab Rep. and Female students (as % of total students) in Syrian Arab Republic?
Your response must be concise. 1.24. What is the ratio of the Female students (as % of total students) of Lower middle income in 1993 to that in 1994?
Make the answer very short. 0.99. What is the ratio of the Female students (as % of total students) in Denmark in 1993 to that in 1994?
Offer a very short reply. 1. What is the ratio of the Female students (as % of total students) in Egypt, Arab Rep. in 1993 to that in 1994?
Offer a very short reply. 1.01. What is the ratio of the Female students (as % of total students) of Syrian Arab Republic in 1993 to that in 1994?
Make the answer very short. 1. What is the ratio of the Female students (as % of total students) of Lower middle income in 1993 to that in 1995?
Give a very brief answer. 0.98. What is the ratio of the Female students (as % of total students) of Denmark in 1993 to that in 1995?
Provide a short and direct response. 1. What is the ratio of the Female students (as % of total students) of Egypt, Arab Rep. in 1993 to that in 1995?
Ensure brevity in your answer.  0.98. What is the ratio of the Female students (as % of total students) in Syrian Arab Republic in 1993 to that in 1995?
Offer a very short reply. 0.99. What is the ratio of the Female students (as % of total students) of Lower middle income in 1993 to that in 1996?
Your answer should be compact. 0.98. What is the ratio of the Female students (as % of total students) in Denmark in 1993 to that in 1996?
Make the answer very short. 1. What is the ratio of the Female students (as % of total students) of Egypt, Arab Rep. in 1993 to that in 1996?
Your response must be concise. 0.97. What is the ratio of the Female students (as % of total students) in Syrian Arab Republic in 1993 to that in 1996?
Your answer should be compact. 0.97. What is the ratio of the Female students (as % of total students) of Lower middle income in 1993 to that in 1998?
Your answer should be very brief. 0.95. What is the ratio of the Female students (as % of total students) in Egypt, Arab Rep. in 1993 to that in 1998?
Your answer should be compact. 0.96. What is the ratio of the Female students (as % of total students) in Syrian Arab Republic in 1993 to that in 1998?
Offer a very short reply. 0.95. What is the ratio of the Female students (as % of total students) of Lower middle income in 1993 to that in 2001?
Offer a terse response. 0.93. What is the ratio of the Female students (as % of total students) in Denmark in 1993 to that in 2001?
Your response must be concise. 0.99. What is the ratio of the Female students (as % of total students) of Egypt, Arab Rep. in 1993 to that in 2001?
Your answer should be compact. 0.93. What is the ratio of the Female students (as % of total students) of Syrian Arab Republic in 1993 to that in 2001?
Ensure brevity in your answer.  0.95. What is the ratio of the Female students (as % of total students) in Lower middle income in 1993 to that in 2003?
Your answer should be very brief. 0.9. What is the ratio of the Female students (as % of total students) in Egypt, Arab Rep. in 1993 to that in 2003?
Provide a succinct answer. 0.93. What is the ratio of the Female students (as % of total students) in Syrian Arab Republic in 1993 to that in 2003?
Your response must be concise. 0.92. What is the ratio of the Female students (as % of total students) in Lower middle income in 1993 to that in 2004?
Provide a short and direct response. 0.9. What is the ratio of the Female students (as % of total students) of Egypt, Arab Rep. in 1993 to that in 2004?
Your answer should be compact. 0.92. What is the ratio of the Female students (as % of total students) in Syrian Arab Republic in 1993 to that in 2004?
Offer a very short reply. 0.92. What is the ratio of the Female students (as % of total students) in Denmark in 1994 to that in 1995?
Your response must be concise. 1. What is the ratio of the Female students (as % of total students) of Egypt, Arab Rep. in 1994 to that in 1995?
Your response must be concise. 0.96. What is the ratio of the Female students (as % of total students) of Syrian Arab Republic in 1994 to that in 1995?
Give a very brief answer. 0.99. What is the ratio of the Female students (as % of total students) of Lower middle income in 1994 to that in 1996?
Provide a short and direct response. 0.99. What is the ratio of the Female students (as % of total students) in Denmark in 1994 to that in 1996?
Give a very brief answer. 1. What is the ratio of the Female students (as % of total students) of Egypt, Arab Rep. in 1994 to that in 1996?
Your answer should be very brief. 0.95. What is the ratio of the Female students (as % of total students) of Syrian Arab Republic in 1994 to that in 1996?
Your response must be concise. 0.97. What is the ratio of the Female students (as % of total students) of Lower middle income in 1994 to that in 1998?
Ensure brevity in your answer.  0.96. What is the ratio of the Female students (as % of total students) in Denmark in 1994 to that in 1998?
Provide a short and direct response. 1. What is the ratio of the Female students (as % of total students) of Egypt, Arab Rep. in 1994 to that in 1998?
Keep it short and to the point. 0.94. What is the ratio of the Female students (as % of total students) of Syrian Arab Republic in 1994 to that in 1998?
Provide a succinct answer. 0.95. What is the ratio of the Female students (as % of total students) of Lower middle income in 1994 to that in 2001?
Provide a short and direct response. 0.94. What is the ratio of the Female students (as % of total students) of Egypt, Arab Rep. in 1994 to that in 2001?
Keep it short and to the point. 0.91. What is the ratio of the Female students (as % of total students) of Syrian Arab Republic in 1994 to that in 2001?
Your response must be concise. 0.95. What is the ratio of the Female students (as % of total students) of Lower middle income in 1994 to that in 2003?
Offer a very short reply. 0.91. What is the ratio of the Female students (as % of total students) of Denmark in 1994 to that in 2003?
Your answer should be compact. 1. What is the ratio of the Female students (as % of total students) of Egypt, Arab Rep. in 1994 to that in 2003?
Give a very brief answer. 0.91. What is the ratio of the Female students (as % of total students) in Syrian Arab Republic in 1994 to that in 2003?
Your answer should be very brief. 0.93. What is the ratio of the Female students (as % of total students) of Lower middle income in 1994 to that in 2004?
Keep it short and to the point. 0.91. What is the ratio of the Female students (as % of total students) in Denmark in 1994 to that in 2004?
Provide a succinct answer. 1. What is the ratio of the Female students (as % of total students) of Egypt, Arab Rep. in 1994 to that in 2004?
Provide a succinct answer. 0.91. What is the ratio of the Female students (as % of total students) of Syrian Arab Republic in 1994 to that in 2004?
Offer a very short reply. 0.92. What is the ratio of the Female students (as % of total students) of Lower middle income in 1995 to that in 1996?
Keep it short and to the point. 0.99. What is the ratio of the Female students (as % of total students) in Egypt, Arab Rep. in 1995 to that in 1996?
Ensure brevity in your answer.  0.99. What is the ratio of the Female students (as % of total students) in Syrian Arab Republic in 1995 to that in 1996?
Ensure brevity in your answer.  0.98. What is the ratio of the Female students (as % of total students) of Lower middle income in 1995 to that in 1998?
Provide a short and direct response. 0.96. What is the ratio of the Female students (as % of total students) in Egypt, Arab Rep. in 1995 to that in 1998?
Keep it short and to the point. 0.98. What is the ratio of the Female students (as % of total students) of Syrian Arab Republic in 1995 to that in 1998?
Keep it short and to the point. 0.96. What is the ratio of the Female students (as % of total students) in Lower middle income in 1995 to that in 2001?
Keep it short and to the point. 0.94. What is the ratio of the Female students (as % of total students) in Egypt, Arab Rep. in 1995 to that in 2001?
Keep it short and to the point. 0.95. What is the ratio of the Female students (as % of total students) of Syrian Arab Republic in 1995 to that in 2001?
Offer a very short reply. 0.96. What is the ratio of the Female students (as % of total students) in Lower middle income in 1995 to that in 2003?
Offer a very short reply. 0.91. What is the ratio of the Female students (as % of total students) of Egypt, Arab Rep. in 1995 to that in 2003?
Give a very brief answer. 0.95. What is the ratio of the Female students (as % of total students) in Syrian Arab Republic in 1995 to that in 2003?
Give a very brief answer. 0.94. What is the ratio of the Female students (as % of total students) in Lower middle income in 1995 to that in 2004?
Keep it short and to the point. 0.92. What is the ratio of the Female students (as % of total students) in Denmark in 1995 to that in 2004?
Keep it short and to the point. 1. What is the ratio of the Female students (as % of total students) in Egypt, Arab Rep. in 1995 to that in 2004?
Provide a succinct answer. 0.94. What is the ratio of the Female students (as % of total students) of Syrian Arab Republic in 1995 to that in 2004?
Make the answer very short. 0.94. What is the ratio of the Female students (as % of total students) of Lower middle income in 1996 to that in 1998?
Ensure brevity in your answer.  0.97. What is the ratio of the Female students (as % of total students) in Denmark in 1996 to that in 1998?
Offer a very short reply. 1. What is the ratio of the Female students (as % of total students) in Egypt, Arab Rep. in 1996 to that in 1998?
Provide a succinct answer. 0.99. What is the ratio of the Female students (as % of total students) in Syrian Arab Republic in 1996 to that in 1998?
Ensure brevity in your answer.  0.98. What is the ratio of the Female students (as % of total students) of Lower middle income in 1996 to that in 2001?
Make the answer very short. 0.95. What is the ratio of the Female students (as % of total students) in Denmark in 1996 to that in 2001?
Give a very brief answer. 0.99. What is the ratio of the Female students (as % of total students) in Egypt, Arab Rep. in 1996 to that in 2001?
Provide a succinct answer. 0.96. What is the ratio of the Female students (as % of total students) in Syrian Arab Republic in 1996 to that in 2001?
Provide a short and direct response. 0.98. What is the ratio of the Female students (as % of total students) in Lower middle income in 1996 to that in 2003?
Make the answer very short. 0.92. What is the ratio of the Female students (as % of total students) of Egypt, Arab Rep. in 1996 to that in 2003?
Your answer should be compact. 0.96. What is the ratio of the Female students (as % of total students) in Syrian Arab Republic in 1996 to that in 2003?
Your answer should be very brief. 0.95. What is the ratio of the Female students (as % of total students) in Lower middle income in 1996 to that in 2004?
Make the answer very short. 0.92. What is the ratio of the Female students (as % of total students) in Egypt, Arab Rep. in 1996 to that in 2004?
Keep it short and to the point. 0.95. What is the ratio of the Female students (as % of total students) in Syrian Arab Republic in 1996 to that in 2004?
Your response must be concise. 0.95. What is the ratio of the Female students (as % of total students) in Lower middle income in 1998 to that in 2001?
Offer a terse response. 0.98. What is the ratio of the Female students (as % of total students) in Egypt, Arab Rep. in 1998 to that in 2001?
Offer a terse response. 0.97. What is the ratio of the Female students (as % of total students) of Syrian Arab Republic in 1998 to that in 2001?
Give a very brief answer. 1. What is the ratio of the Female students (as % of total students) of Lower middle income in 1998 to that in 2003?
Your response must be concise. 0.95. What is the ratio of the Female students (as % of total students) of Denmark in 1998 to that in 2003?
Your answer should be very brief. 1. What is the ratio of the Female students (as % of total students) in Egypt, Arab Rep. in 1998 to that in 2003?
Make the answer very short. 0.97. What is the ratio of the Female students (as % of total students) of Syrian Arab Republic in 1998 to that in 2003?
Your answer should be compact. 0.98. What is the ratio of the Female students (as % of total students) in Lower middle income in 1998 to that in 2004?
Give a very brief answer. 0.95. What is the ratio of the Female students (as % of total students) in Denmark in 1998 to that in 2004?
Your answer should be compact. 1. What is the ratio of the Female students (as % of total students) of Egypt, Arab Rep. in 1998 to that in 2004?
Your answer should be compact. 0.96. What is the ratio of the Female students (as % of total students) in Syrian Arab Republic in 1998 to that in 2004?
Your response must be concise. 0.97. What is the ratio of the Female students (as % of total students) of Egypt, Arab Rep. in 2001 to that in 2003?
Your response must be concise. 1. What is the ratio of the Female students (as % of total students) in Syrian Arab Republic in 2001 to that in 2003?
Provide a short and direct response. 0.98. What is the ratio of the Female students (as % of total students) of Lower middle income in 2001 to that in 2004?
Your answer should be very brief. 0.97. What is the ratio of the Female students (as % of total students) of Denmark in 2001 to that in 2004?
Provide a short and direct response. 1.01. What is the ratio of the Female students (as % of total students) of Denmark in 2003 to that in 2004?
Your response must be concise. 1. What is the ratio of the Female students (as % of total students) in Syrian Arab Republic in 2003 to that in 2004?
Provide a short and direct response. 1. What is the difference between the highest and the second highest Female students (as % of total students) of Lower middle income?
Your answer should be compact. 0.15. What is the difference between the highest and the second highest Female students (as % of total students) in Denmark?
Make the answer very short. 0.18. What is the difference between the highest and the second highest Female students (as % of total students) of Egypt, Arab Rep.?
Provide a short and direct response. 0.37. What is the difference between the highest and the second highest Female students (as % of total students) of Syrian Arab Republic?
Offer a terse response. 0.14. What is the difference between the highest and the lowest Female students (as % of total students) in Lower middle income?
Offer a very short reply. 4.66. What is the difference between the highest and the lowest Female students (as % of total students) of Denmark?
Give a very brief answer. 0.45. What is the difference between the highest and the lowest Female students (as % of total students) of Egypt, Arab Rep.?
Keep it short and to the point. 4.59. What is the difference between the highest and the lowest Female students (as % of total students) of Syrian Arab Republic?
Your answer should be compact. 3.7. 